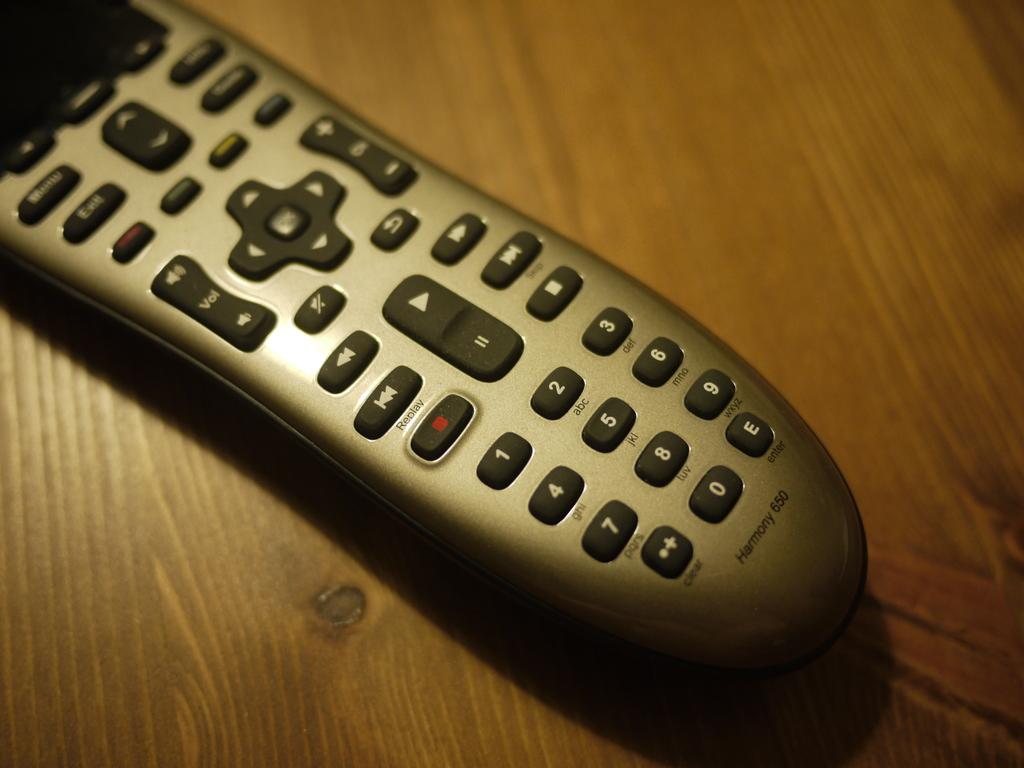What is this?
Offer a very short reply. Answering does not require reading text in the image. 